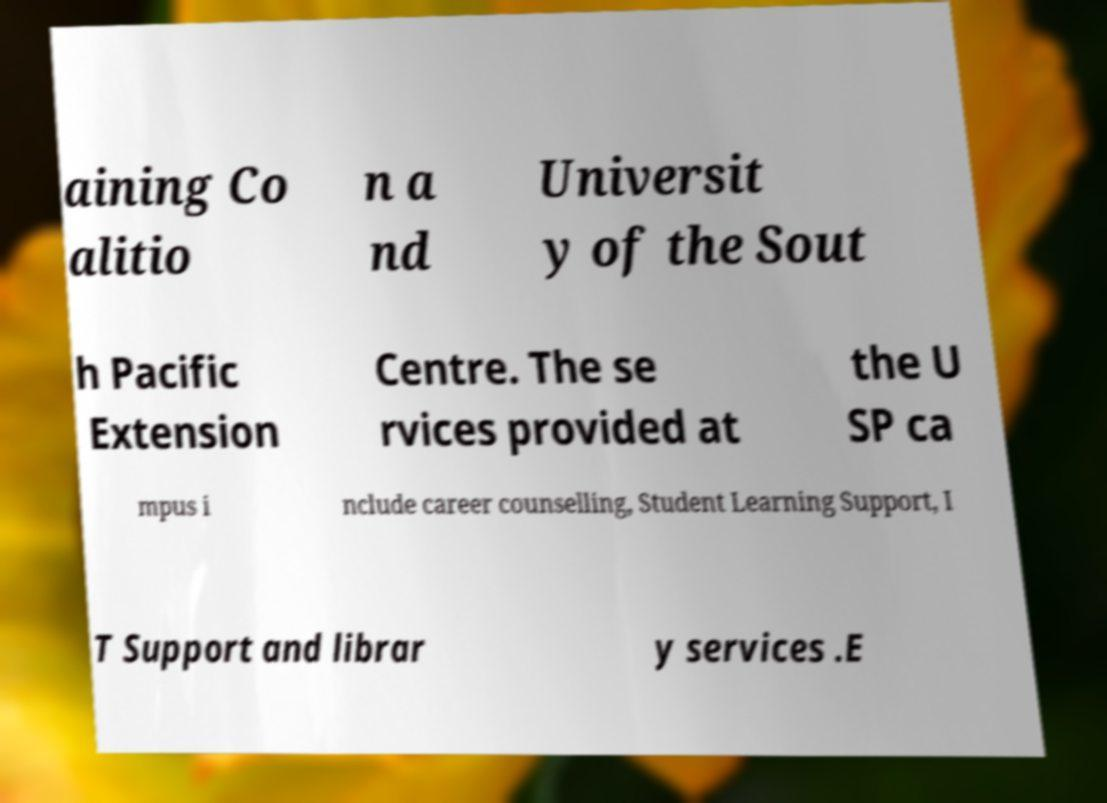Can you read and provide the text displayed in the image?This photo seems to have some interesting text. Can you extract and type it out for me? aining Co alitio n a nd Universit y of the Sout h Pacific Extension Centre. The se rvices provided at the U SP ca mpus i nclude career counselling, Student Learning Support, I T Support and librar y services .E 